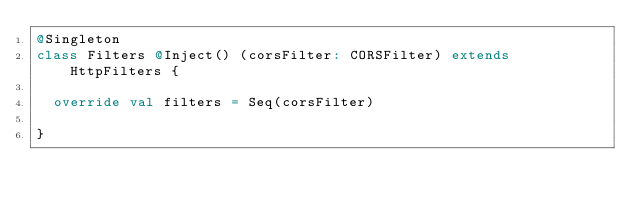<code> <loc_0><loc_0><loc_500><loc_500><_Scala_>@Singleton
class Filters @Inject() (corsFilter: CORSFilter) extends HttpFilters {

  override val filters = Seq(corsFilter)

}
</code> 